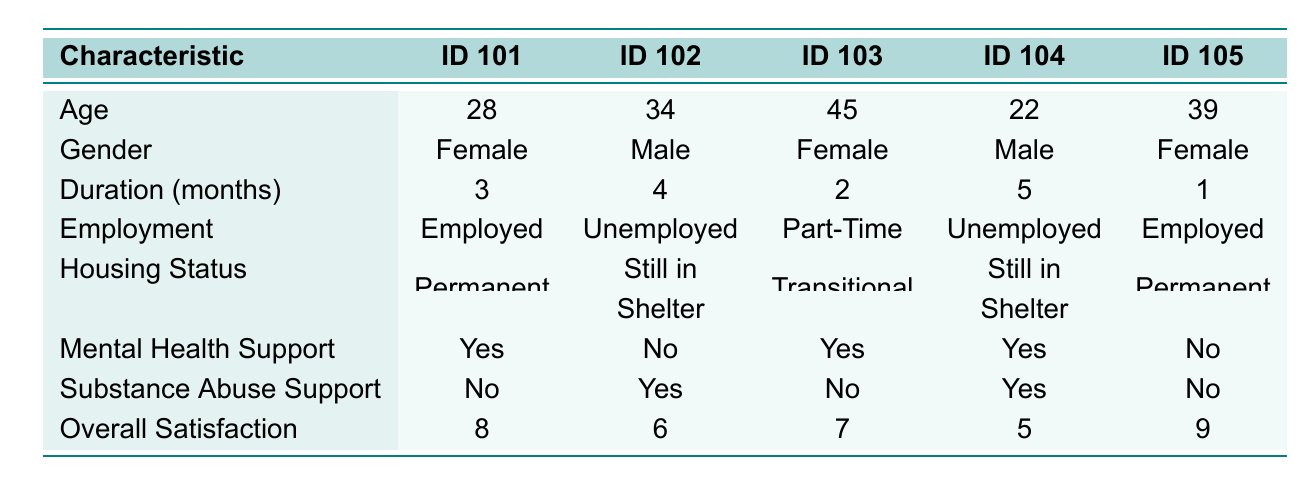What is the housing status of individual ID 101? The table indicates that for individual ID 101, the housing status is listed as "Permanent Housing". Therefore, we can directly refer to the corresponding row and column for this information.
Answer: Permanent Housing How many individuals in the shelter are employed? By checking the employment status column, I can see individual IDs 101 and 105 are marked as "Employed". Counting these, there are 2 people with this status.
Answer: 2 What is the overall satisfaction score of the individual who has been in the shelter the longest? The individual with the longest duration in the shelter is ID 104, who has been there for 5 months. Their overall satisfaction score is listed as 5, which can be found in the corresponding row.
Answer: 5 How many individuals receive mental health support? Referring to the mental health support column, I can see that individuals ID 101, 103, and 104 receive mental health support (indicated by "Yes"). Counting these responses shows that there are 3 individuals receiving support.
Answer: 3 What is the average overall satisfaction score of individuals who are unemployed? The overall satisfaction scores for unemployed individuals (ID 102 and ID 104) are 6 and 5, respectively. To find the average, I sum these scores (6 + 5 = 11) and then divide by the number of unemployed individuals (2). This gives an average score of 11/2 = 5.5.
Answer: 5.5 Is there any individual who is both unemployed and receives substance abuse support? Looking across the table, individual ID 102 is unemployed and receives substance abuse support, as indicated by "Yes". Therefore, there is an individual that meets these criteria.
Answer: Yes What is the difference in overall satisfaction scores between individuals receiving substance abuse support and those who are not? For individuals receiving substance abuse support (ID 102 and ID 104), their scores are 6 and 5, which average at (6 + 5) / 2 = 5.5. For those not receiving support (ID 101, 103, and 105), their scores are 8, 7, and 9, averaging to (8 + 7 + 9) / 3 = 8. Hence, the difference in average scores is 8 - 5.5 = 2.5.
Answer: 2.5 What is the duration in the shelter of the youngest individual? The youngest individual based on the age column is ID 104 who is 22 years old. The duration in the shelter for this individual is listed as 5 months, which can be identified directly in the table.
Answer: 5 months How many individuals are in transitional housing? From the housing status column, it's clear that only individual ID 103 is in "Transitional Housing". Hence, there is only one individual in that category.
Answer: 1 